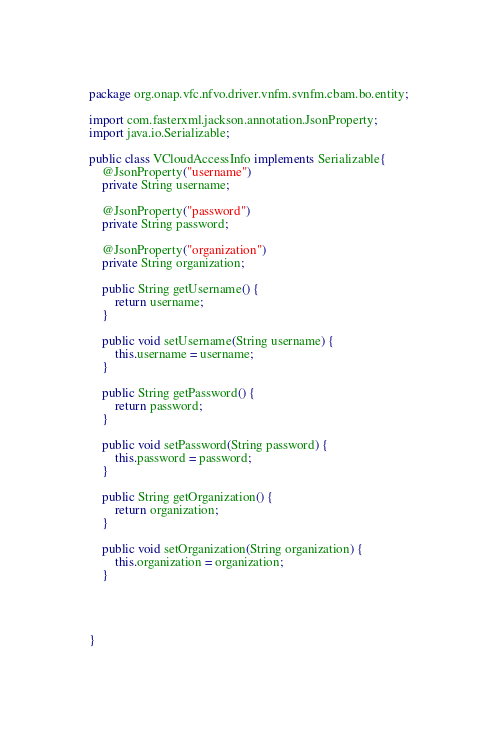Convert code to text. <code><loc_0><loc_0><loc_500><loc_500><_Java_>package org.onap.vfc.nfvo.driver.vnfm.svnfm.cbam.bo.entity;

import com.fasterxml.jackson.annotation.JsonProperty;
import java.io.Serializable;

public class VCloudAccessInfo implements Serializable{
	@JsonProperty("username")
	private String username;
	
	@JsonProperty("password")
	private String password;
	
	@JsonProperty("organization")
	private String organization;

	public String getUsername() {
		return username;
	}

	public void setUsername(String username) {
		this.username = username;
	}

	public String getPassword() {
		return password;
	}

	public void setPassword(String password) {
		this.password = password;
	}

	public String getOrganization() {
		return organization;
	}

	public void setOrganization(String organization) {
		this.organization = organization;
	}
	
	
	
	
}
</code> 